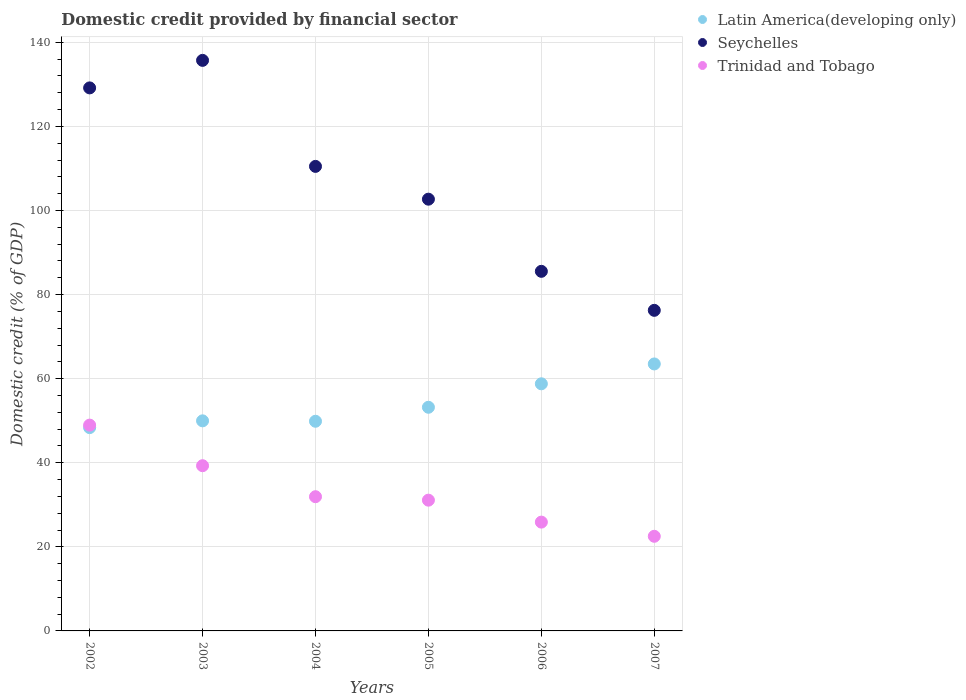How many different coloured dotlines are there?
Your answer should be very brief. 3. What is the domestic credit in Seychelles in 2006?
Keep it short and to the point. 85.53. Across all years, what is the maximum domestic credit in Latin America(developing only)?
Keep it short and to the point. 63.5. Across all years, what is the minimum domestic credit in Seychelles?
Provide a short and direct response. 76.25. What is the total domestic credit in Trinidad and Tobago in the graph?
Your answer should be very brief. 199.66. What is the difference between the domestic credit in Latin America(developing only) in 2004 and that in 2005?
Your answer should be very brief. -3.33. What is the difference between the domestic credit in Trinidad and Tobago in 2002 and the domestic credit in Latin America(developing only) in 2005?
Provide a short and direct response. -4.25. What is the average domestic credit in Latin America(developing only) per year?
Provide a short and direct response. 53.95. In the year 2007, what is the difference between the domestic credit in Latin America(developing only) and domestic credit in Trinidad and Tobago?
Offer a very short reply. 40.99. In how many years, is the domestic credit in Latin America(developing only) greater than 56 %?
Provide a short and direct response. 2. What is the ratio of the domestic credit in Latin America(developing only) in 2002 to that in 2005?
Your answer should be very brief. 0.91. Is the domestic credit in Trinidad and Tobago in 2003 less than that in 2005?
Provide a succinct answer. No. Is the difference between the domestic credit in Latin America(developing only) in 2002 and 2003 greater than the difference between the domestic credit in Trinidad and Tobago in 2002 and 2003?
Keep it short and to the point. No. What is the difference between the highest and the second highest domestic credit in Latin America(developing only)?
Your answer should be compact. 4.72. What is the difference between the highest and the lowest domestic credit in Latin America(developing only)?
Keep it short and to the point. 15.15. In how many years, is the domestic credit in Trinidad and Tobago greater than the average domestic credit in Trinidad and Tobago taken over all years?
Your answer should be compact. 2. Is the sum of the domestic credit in Seychelles in 2004 and 2006 greater than the maximum domestic credit in Trinidad and Tobago across all years?
Offer a very short reply. Yes. Is it the case that in every year, the sum of the domestic credit in Seychelles and domestic credit in Trinidad and Tobago  is greater than the domestic credit in Latin America(developing only)?
Ensure brevity in your answer.  Yes. Does the domestic credit in Latin America(developing only) monotonically increase over the years?
Your response must be concise. No. Is the domestic credit in Latin America(developing only) strictly less than the domestic credit in Trinidad and Tobago over the years?
Provide a succinct answer. No. Does the graph contain any zero values?
Give a very brief answer. No. Does the graph contain grids?
Offer a terse response. Yes. How many legend labels are there?
Offer a terse response. 3. How are the legend labels stacked?
Offer a very short reply. Vertical. What is the title of the graph?
Give a very brief answer. Domestic credit provided by financial sector. What is the label or title of the X-axis?
Make the answer very short. Years. What is the label or title of the Y-axis?
Provide a succinct answer. Domestic credit (% of GDP). What is the Domestic credit (% of GDP) of Latin America(developing only) in 2002?
Keep it short and to the point. 48.36. What is the Domestic credit (% of GDP) in Seychelles in 2002?
Offer a very short reply. 129.16. What is the Domestic credit (% of GDP) of Trinidad and Tobago in 2002?
Give a very brief answer. 48.95. What is the Domestic credit (% of GDP) of Latin America(developing only) in 2003?
Make the answer very short. 49.97. What is the Domestic credit (% of GDP) of Seychelles in 2003?
Ensure brevity in your answer.  135.71. What is the Domestic credit (% of GDP) of Trinidad and Tobago in 2003?
Your response must be concise. 39.3. What is the Domestic credit (% of GDP) in Latin America(developing only) in 2004?
Give a very brief answer. 49.87. What is the Domestic credit (% of GDP) in Seychelles in 2004?
Your answer should be very brief. 110.49. What is the Domestic credit (% of GDP) of Trinidad and Tobago in 2004?
Make the answer very short. 31.92. What is the Domestic credit (% of GDP) of Latin America(developing only) in 2005?
Your answer should be very brief. 53.2. What is the Domestic credit (% of GDP) in Seychelles in 2005?
Your response must be concise. 102.69. What is the Domestic credit (% of GDP) of Trinidad and Tobago in 2005?
Your answer should be compact. 31.1. What is the Domestic credit (% of GDP) of Latin America(developing only) in 2006?
Your answer should be very brief. 58.78. What is the Domestic credit (% of GDP) of Seychelles in 2006?
Your answer should be compact. 85.53. What is the Domestic credit (% of GDP) in Trinidad and Tobago in 2006?
Provide a short and direct response. 25.88. What is the Domestic credit (% of GDP) of Latin America(developing only) in 2007?
Your answer should be very brief. 63.5. What is the Domestic credit (% of GDP) in Seychelles in 2007?
Provide a short and direct response. 76.25. What is the Domestic credit (% of GDP) of Trinidad and Tobago in 2007?
Offer a terse response. 22.51. Across all years, what is the maximum Domestic credit (% of GDP) of Latin America(developing only)?
Provide a succinct answer. 63.5. Across all years, what is the maximum Domestic credit (% of GDP) in Seychelles?
Give a very brief answer. 135.71. Across all years, what is the maximum Domestic credit (% of GDP) in Trinidad and Tobago?
Provide a short and direct response. 48.95. Across all years, what is the minimum Domestic credit (% of GDP) in Latin America(developing only)?
Keep it short and to the point. 48.36. Across all years, what is the minimum Domestic credit (% of GDP) in Seychelles?
Give a very brief answer. 76.25. Across all years, what is the minimum Domestic credit (% of GDP) in Trinidad and Tobago?
Offer a very short reply. 22.51. What is the total Domestic credit (% of GDP) of Latin America(developing only) in the graph?
Make the answer very short. 323.67. What is the total Domestic credit (% of GDP) in Seychelles in the graph?
Offer a terse response. 639.84. What is the total Domestic credit (% of GDP) of Trinidad and Tobago in the graph?
Keep it short and to the point. 199.66. What is the difference between the Domestic credit (% of GDP) in Latin America(developing only) in 2002 and that in 2003?
Offer a terse response. -1.61. What is the difference between the Domestic credit (% of GDP) in Seychelles in 2002 and that in 2003?
Provide a short and direct response. -6.55. What is the difference between the Domestic credit (% of GDP) of Trinidad and Tobago in 2002 and that in 2003?
Provide a short and direct response. 9.65. What is the difference between the Domestic credit (% of GDP) in Latin America(developing only) in 2002 and that in 2004?
Offer a terse response. -1.51. What is the difference between the Domestic credit (% of GDP) of Seychelles in 2002 and that in 2004?
Keep it short and to the point. 18.67. What is the difference between the Domestic credit (% of GDP) in Trinidad and Tobago in 2002 and that in 2004?
Your answer should be compact. 17.03. What is the difference between the Domestic credit (% of GDP) of Latin America(developing only) in 2002 and that in 2005?
Provide a succinct answer. -4.84. What is the difference between the Domestic credit (% of GDP) of Seychelles in 2002 and that in 2005?
Keep it short and to the point. 26.47. What is the difference between the Domestic credit (% of GDP) in Trinidad and Tobago in 2002 and that in 2005?
Provide a succinct answer. 17.85. What is the difference between the Domestic credit (% of GDP) of Latin America(developing only) in 2002 and that in 2006?
Keep it short and to the point. -10.42. What is the difference between the Domestic credit (% of GDP) of Seychelles in 2002 and that in 2006?
Your answer should be compact. 43.63. What is the difference between the Domestic credit (% of GDP) in Trinidad and Tobago in 2002 and that in 2006?
Give a very brief answer. 23.07. What is the difference between the Domestic credit (% of GDP) of Latin America(developing only) in 2002 and that in 2007?
Provide a short and direct response. -15.15. What is the difference between the Domestic credit (% of GDP) of Seychelles in 2002 and that in 2007?
Give a very brief answer. 52.91. What is the difference between the Domestic credit (% of GDP) of Trinidad and Tobago in 2002 and that in 2007?
Give a very brief answer. 26.44. What is the difference between the Domestic credit (% of GDP) in Latin America(developing only) in 2003 and that in 2004?
Provide a succinct answer. 0.1. What is the difference between the Domestic credit (% of GDP) of Seychelles in 2003 and that in 2004?
Your answer should be compact. 25.22. What is the difference between the Domestic credit (% of GDP) of Trinidad and Tobago in 2003 and that in 2004?
Keep it short and to the point. 7.37. What is the difference between the Domestic credit (% of GDP) in Latin America(developing only) in 2003 and that in 2005?
Provide a short and direct response. -3.23. What is the difference between the Domestic credit (% of GDP) in Seychelles in 2003 and that in 2005?
Keep it short and to the point. 33.02. What is the difference between the Domestic credit (% of GDP) in Trinidad and Tobago in 2003 and that in 2005?
Your response must be concise. 8.2. What is the difference between the Domestic credit (% of GDP) of Latin America(developing only) in 2003 and that in 2006?
Your answer should be very brief. -8.81. What is the difference between the Domestic credit (% of GDP) of Seychelles in 2003 and that in 2006?
Your response must be concise. 50.18. What is the difference between the Domestic credit (% of GDP) in Trinidad and Tobago in 2003 and that in 2006?
Your answer should be very brief. 13.42. What is the difference between the Domestic credit (% of GDP) in Latin America(developing only) in 2003 and that in 2007?
Offer a very short reply. -13.53. What is the difference between the Domestic credit (% of GDP) of Seychelles in 2003 and that in 2007?
Make the answer very short. 59.46. What is the difference between the Domestic credit (% of GDP) in Trinidad and Tobago in 2003 and that in 2007?
Make the answer very short. 16.79. What is the difference between the Domestic credit (% of GDP) of Latin America(developing only) in 2004 and that in 2005?
Ensure brevity in your answer.  -3.33. What is the difference between the Domestic credit (% of GDP) in Seychelles in 2004 and that in 2005?
Ensure brevity in your answer.  7.8. What is the difference between the Domestic credit (% of GDP) of Trinidad and Tobago in 2004 and that in 2005?
Keep it short and to the point. 0.82. What is the difference between the Domestic credit (% of GDP) in Latin America(developing only) in 2004 and that in 2006?
Offer a very short reply. -8.91. What is the difference between the Domestic credit (% of GDP) in Seychelles in 2004 and that in 2006?
Provide a short and direct response. 24.96. What is the difference between the Domestic credit (% of GDP) in Trinidad and Tobago in 2004 and that in 2006?
Make the answer very short. 6.04. What is the difference between the Domestic credit (% of GDP) in Latin America(developing only) in 2004 and that in 2007?
Keep it short and to the point. -13.63. What is the difference between the Domestic credit (% of GDP) of Seychelles in 2004 and that in 2007?
Ensure brevity in your answer.  34.24. What is the difference between the Domestic credit (% of GDP) of Trinidad and Tobago in 2004 and that in 2007?
Ensure brevity in your answer.  9.42. What is the difference between the Domestic credit (% of GDP) in Latin America(developing only) in 2005 and that in 2006?
Give a very brief answer. -5.58. What is the difference between the Domestic credit (% of GDP) in Seychelles in 2005 and that in 2006?
Ensure brevity in your answer.  17.16. What is the difference between the Domestic credit (% of GDP) of Trinidad and Tobago in 2005 and that in 2006?
Give a very brief answer. 5.22. What is the difference between the Domestic credit (% of GDP) in Latin America(developing only) in 2005 and that in 2007?
Your response must be concise. -10.3. What is the difference between the Domestic credit (% of GDP) of Seychelles in 2005 and that in 2007?
Offer a terse response. 26.44. What is the difference between the Domestic credit (% of GDP) of Trinidad and Tobago in 2005 and that in 2007?
Ensure brevity in your answer.  8.59. What is the difference between the Domestic credit (% of GDP) in Latin America(developing only) in 2006 and that in 2007?
Your response must be concise. -4.72. What is the difference between the Domestic credit (% of GDP) in Seychelles in 2006 and that in 2007?
Your answer should be very brief. 9.28. What is the difference between the Domestic credit (% of GDP) of Trinidad and Tobago in 2006 and that in 2007?
Provide a short and direct response. 3.37. What is the difference between the Domestic credit (% of GDP) in Latin America(developing only) in 2002 and the Domestic credit (% of GDP) in Seychelles in 2003?
Ensure brevity in your answer.  -87.35. What is the difference between the Domestic credit (% of GDP) of Latin America(developing only) in 2002 and the Domestic credit (% of GDP) of Trinidad and Tobago in 2003?
Your response must be concise. 9.06. What is the difference between the Domestic credit (% of GDP) of Seychelles in 2002 and the Domestic credit (% of GDP) of Trinidad and Tobago in 2003?
Your answer should be very brief. 89.87. What is the difference between the Domestic credit (% of GDP) in Latin America(developing only) in 2002 and the Domestic credit (% of GDP) in Seychelles in 2004?
Your answer should be compact. -62.14. What is the difference between the Domestic credit (% of GDP) in Latin America(developing only) in 2002 and the Domestic credit (% of GDP) in Trinidad and Tobago in 2004?
Offer a very short reply. 16.43. What is the difference between the Domestic credit (% of GDP) of Seychelles in 2002 and the Domestic credit (% of GDP) of Trinidad and Tobago in 2004?
Keep it short and to the point. 97.24. What is the difference between the Domestic credit (% of GDP) in Latin America(developing only) in 2002 and the Domestic credit (% of GDP) in Seychelles in 2005?
Keep it short and to the point. -54.34. What is the difference between the Domestic credit (% of GDP) in Latin America(developing only) in 2002 and the Domestic credit (% of GDP) in Trinidad and Tobago in 2005?
Ensure brevity in your answer.  17.26. What is the difference between the Domestic credit (% of GDP) in Seychelles in 2002 and the Domestic credit (% of GDP) in Trinidad and Tobago in 2005?
Offer a very short reply. 98.06. What is the difference between the Domestic credit (% of GDP) in Latin America(developing only) in 2002 and the Domestic credit (% of GDP) in Seychelles in 2006?
Keep it short and to the point. -37.18. What is the difference between the Domestic credit (% of GDP) in Latin America(developing only) in 2002 and the Domestic credit (% of GDP) in Trinidad and Tobago in 2006?
Make the answer very short. 22.48. What is the difference between the Domestic credit (% of GDP) in Seychelles in 2002 and the Domestic credit (% of GDP) in Trinidad and Tobago in 2006?
Ensure brevity in your answer.  103.28. What is the difference between the Domestic credit (% of GDP) of Latin America(developing only) in 2002 and the Domestic credit (% of GDP) of Seychelles in 2007?
Offer a terse response. -27.9. What is the difference between the Domestic credit (% of GDP) of Latin America(developing only) in 2002 and the Domestic credit (% of GDP) of Trinidad and Tobago in 2007?
Offer a terse response. 25.85. What is the difference between the Domestic credit (% of GDP) of Seychelles in 2002 and the Domestic credit (% of GDP) of Trinidad and Tobago in 2007?
Offer a terse response. 106.66. What is the difference between the Domestic credit (% of GDP) in Latin America(developing only) in 2003 and the Domestic credit (% of GDP) in Seychelles in 2004?
Offer a terse response. -60.52. What is the difference between the Domestic credit (% of GDP) in Latin America(developing only) in 2003 and the Domestic credit (% of GDP) in Trinidad and Tobago in 2004?
Give a very brief answer. 18.04. What is the difference between the Domestic credit (% of GDP) in Seychelles in 2003 and the Domestic credit (% of GDP) in Trinidad and Tobago in 2004?
Your answer should be compact. 103.79. What is the difference between the Domestic credit (% of GDP) in Latin America(developing only) in 2003 and the Domestic credit (% of GDP) in Seychelles in 2005?
Make the answer very short. -52.72. What is the difference between the Domestic credit (% of GDP) of Latin America(developing only) in 2003 and the Domestic credit (% of GDP) of Trinidad and Tobago in 2005?
Provide a succinct answer. 18.87. What is the difference between the Domestic credit (% of GDP) of Seychelles in 2003 and the Domestic credit (% of GDP) of Trinidad and Tobago in 2005?
Your response must be concise. 104.61. What is the difference between the Domestic credit (% of GDP) of Latin America(developing only) in 2003 and the Domestic credit (% of GDP) of Seychelles in 2006?
Provide a short and direct response. -35.56. What is the difference between the Domestic credit (% of GDP) of Latin America(developing only) in 2003 and the Domestic credit (% of GDP) of Trinidad and Tobago in 2006?
Offer a very short reply. 24.09. What is the difference between the Domestic credit (% of GDP) in Seychelles in 2003 and the Domestic credit (% of GDP) in Trinidad and Tobago in 2006?
Make the answer very short. 109.83. What is the difference between the Domestic credit (% of GDP) in Latin America(developing only) in 2003 and the Domestic credit (% of GDP) in Seychelles in 2007?
Provide a short and direct response. -26.28. What is the difference between the Domestic credit (% of GDP) in Latin America(developing only) in 2003 and the Domestic credit (% of GDP) in Trinidad and Tobago in 2007?
Offer a terse response. 27.46. What is the difference between the Domestic credit (% of GDP) in Seychelles in 2003 and the Domestic credit (% of GDP) in Trinidad and Tobago in 2007?
Offer a terse response. 113.2. What is the difference between the Domestic credit (% of GDP) of Latin America(developing only) in 2004 and the Domestic credit (% of GDP) of Seychelles in 2005?
Your answer should be very brief. -52.82. What is the difference between the Domestic credit (% of GDP) of Latin America(developing only) in 2004 and the Domestic credit (% of GDP) of Trinidad and Tobago in 2005?
Your answer should be very brief. 18.77. What is the difference between the Domestic credit (% of GDP) in Seychelles in 2004 and the Domestic credit (% of GDP) in Trinidad and Tobago in 2005?
Your response must be concise. 79.39. What is the difference between the Domestic credit (% of GDP) of Latin America(developing only) in 2004 and the Domestic credit (% of GDP) of Seychelles in 2006?
Ensure brevity in your answer.  -35.66. What is the difference between the Domestic credit (% of GDP) of Latin America(developing only) in 2004 and the Domestic credit (% of GDP) of Trinidad and Tobago in 2006?
Your answer should be very brief. 23.99. What is the difference between the Domestic credit (% of GDP) in Seychelles in 2004 and the Domestic credit (% of GDP) in Trinidad and Tobago in 2006?
Keep it short and to the point. 84.61. What is the difference between the Domestic credit (% of GDP) in Latin America(developing only) in 2004 and the Domestic credit (% of GDP) in Seychelles in 2007?
Offer a terse response. -26.38. What is the difference between the Domestic credit (% of GDP) of Latin America(developing only) in 2004 and the Domestic credit (% of GDP) of Trinidad and Tobago in 2007?
Offer a terse response. 27.36. What is the difference between the Domestic credit (% of GDP) of Seychelles in 2004 and the Domestic credit (% of GDP) of Trinidad and Tobago in 2007?
Offer a very short reply. 87.98. What is the difference between the Domestic credit (% of GDP) of Latin America(developing only) in 2005 and the Domestic credit (% of GDP) of Seychelles in 2006?
Offer a very short reply. -32.33. What is the difference between the Domestic credit (% of GDP) of Latin America(developing only) in 2005 and the Domestic credit (% of GDP) of Trinidad and Tobago in 2006?
Provide a short and direct response. 27.32. What is the difference between the Domestic credit (% of GDP) in Seychelles in 2005 and the Domestic credit (% of GDP) in Trinidad and Tobago in 2006?
Make the answer very short. 76.81. What is the difference between the Domestic credit (% of GDP) of Latin America(developing only) in 2005 and the Domestic credit (% of GDP) of Seychelles in 2007?
Give a very brief answer. -23.05. What is the difference between the Domestic credit (% of GDP) in Latin America(developing only) in 2005 and the Domestic credit (% of GDP) in Trinidad and Tobago in 2007?
Ensure brevity in your answer.  30.69. What is the difference between the Domestic credit (% of GDP) in Seychelles in 2005 and the Domestic credit (% of GDP) in Trinidad and Tobago in 2007?
Your response must be concise. 80.19. What is the difference between the Domestic credit (% of GDP) of Latin America(developing only) in 2006 and the Domestic credit (% of GDP) of Seychelles in 2007?
Your answer should be compact. -17.47. What is the difference between the Domestic credit (% of GDP) of Latin America(developing only) in 2006 and the Domestic credit (% of GDP) of Trinidad and Tobago in 2007?
Provide a short and direct response. 36.27. What is the difference between the Domestic credit (% of GDP) in Seychelles in 2006 and the Domestic credit (% of GDP) in Trinidad and Tobago in 2007?
Keep it short and to the point. 63.02. What is the average Domestic credit (% of GDP) of Latin America(developing only) per year?
Your answer should be very brief. 53.95. What is the average Domestic credit (% of GDP) in Seychelles per year?
Provide a succinct answer. 106.64. What is the average Domestic credit (% of GDP) in Trinidad and Tobago per year?
Offer a terse response. 33.28. In the year 2002, what is the difference between the Domestic credit (% of GDP) of Latin America(developing only) and Domestic credit (% of GDP) of Seychelles?
Provide a short and direct response. -80.81. In the year 2002, what is the difference between the Domestic credit (% of GDP) in Latin America(developing only) and Domestic credit (% of GDP) in Trinidad and Tobago?
Provide a succinct answer. -0.6. In the year 2002, what is the difference between the Domestic credit (% of GDP) of Seychelles and Domestic credit (% of GDP) of Trinidad and Tobago?
Provide a short and direct response. 80.21. In the year 2003, what is the difference between the Domestic credit (% of GDP) in Latin America(developing only) and Domestic credit (% of GDP) in Seychelles?
Give a very brief answer. -85.74. In the year 2003, what is the difference between the Domestic credit (% of GDP) in Latin America(developing only) and Domestic credit (% of GDP) in Trinidad and Tobago?
Your answer should be very brief. 10.67. In the year 2003, what is the difference between the Domestic credit (% of GDP) in Seychelles and Domestic credit (% of GDP) in Trinidad and Tobago?
Offer a terse response. 96.41. In the year 2004, what is the difference between the Domestic credit (% of GDP) in Latin America(developing only) and Domestic credit (% of GDP) in Seychelles?
Your answer should be compact. -60.62. In the year 2004, what is the difference between the Domestic credit (% of GDP) in Latin America(developing only) and Domestic credit (% of GDP) in Trinidad and Tobago?
Offer a very short reply. 17.95. In the year 2004, what is the difference between the Domestic credit (% of GDP) of Seychelles and Domestic credit (% of GDP) of Trinidad and Tobago?
Your answer should be very brief. 78.57. In the year 2005, what is the difference between the Domestic credit (% of GDP) of Latin America(developing only) and Domestic credit (% of GDP) of Seychelles?
Keep it short and to the point. -49.49. In the year 2005, what is the difference between the Domestic credit (% of GDP) in Latin America(developing only) and Domestic credit (% of GDP) in Trinidad and Tobago?
Your answer should be compact. 22.1. In the year 2005, what is the difference between the Domestic credit (% of GDP) in Seychelles and Domestic credit (% of GDP) in Trinidad and Tobago?
Offer a terse response. 71.59. In the year 2006, what is the difference between the Domestic credit (% of GDP) in Latin America(developing only) and Domestic credit (% of GDP) in Seychelles?
Provide a short and direct response. -26.75. In the year 2006, what is the difference between the Domestic credit (% of GDP) in Latin America(developing only) and Domestic credit (% of GDP) in Trinidad and Tobago?
Offer a very short reply. 32.9. In the year 2006, what is the difference between the Domestic credit (% of GDP) of Seychelles and Domestic credit (% of GDP) of Trinidad and Tobago?
Make the answer very short. 59.65. In the year 2007, what is the difference between the Domestic credit (% of GDP) in Latin America(developing only) and Domestic credit (% of GDP) in Seychelles?
Keep it short and to the point. -12.75. In the year 2007, what is the difference between the Domestic credit (% of GDP) in Latin America(developing only) and Domestic credit (% of GDP) in Trinidad and Tobago?
Your answer should be compact. 40.99. In the year 2007, what is the difference between the Domestic credit (% of GDP) of Seychelles and Domestic credit (% of GDP) of Trinidad and Tobago?
Make the answer very short. 53.74. What is the ratio of the Domestic credit (% of GDP) in Latin America(developing only) in 2002 to that in 2003?
Make the answer very short. 0.97. What is the ratio of the Domestic credit (% of GDP) of Seychelles in 2002 to that in 2003?
Provide a succinct answer. 0.95. What is the ratio of the Domestic credit (% of GDP) of Trinidad and Tobago in 2002 to that in 2003?
Make the answer very short. 1.25. What is the ratio of the Domestic credit (% of GDP) of Latin America(developing only) in 2002 to that in 2004?
Provide a succinct answer. 0.97. What is the ratio of the Domestic credit (% of GDP) of Seychelles in 2002 to that in 2004?
Provide a succinct answer. 1.17. What is the ratio of the Domestic credit (% of GDP) in Trinidad and Tobago in 2002 to that in 2004?
Provide a succinct answer. 1.53. What is the ratio of the Domestic credit (% of GDP) of Latin America(developing only) in 2002 to that in 2005?
Provide a short and direct response. 0.91. What is the ratio of the Domestic credit (% of GDP) in Seychelles in 2002 to that in 2005?
Offer a terse response. 1.26. What is the ratio of the Domestic credit (% of GDP) in Trinidad and Tobago in 2002 to that in 2005?
Make the answer very short. 1.57. What is the ratio of the Domestic credit (% of GDP) of Latin America(developing only) in 2002 to that in 2006?
Give a very brief answer. 0.82. What is the ratio of the Domestic credit (% of GDP) of Seychelles in 2002 to that in 2006?
Provide a short and direct response. 1.51. What is the ratio of the Domestic credit (% of GDP) of Trinidad and Tobago in 2002 to that in 2006?
Your answer should be very brief. 1.89. What is the ratio of the Domestic credit (% of GDP) of Latin America(developing only) in 2002 to that in 2007?
Provide a succinct answer. 0.76. What is the ratio of the Domestic credit (% of GDP) in Seychelles in 2002 to that in 2007?
Your answer should be compact. 1.69. What is the ratio of the Domestic credit (% of GDP) in Trinidad and Tobago in 2002 to that in 2007?
Give a very brief answer. 2.17. What is the ratio of the Domestic credit (% of GDP) of Latin America(developing only) in 2003 to that in 2004?
Make the answer very short. 1. What is the ratio of the Domestic credit (% of GDP) in Seychelles in 2003 to that in 2004?
Keep it short and to the point. 1.23. What is the ratio of the Domestic credit (% of GDP) of Trinidad and Tobago in 2003 to that in 2004?
Keep it short and to the point. 1.23. What is the ratio of the Domestic credit (% of GDP) in Latin America(developing only) in 2003 to that in 2005?
Give a very brief answer. 0.94. What is the ratio of the Domestic credit (% of GDP) in Seychelles in 2003 to that in 2005?
Offer a very short reply. 1.32. What is the ratio of the Domestic credit (% of GDP) in Trinidad and Tobago in 2003 to that in 2005?
Ensure brevity in your answer.  1.26. What is the ratio of the Domestic credit (% of GDP) in Latin America(developing only) in 2003 to that in 2006?
Your answer should be very brief. 0.85. What is the ratio of the Domestic credit (% of GDP) of Seychelles in 2003 to that in 2006?
Make the answer very short. 1.59. What is the ratio of the Domestic credit (% of GDP) of Trinidad and Tobago in 2003 to that in 2006?
Your answer should be compact. 1.52. What is the ratio of the Domestic credit (% of GDP) in Latin America(developing only) in 2003 to that in 2007?
Offer a terse response. 0.79. What is the ratio of the Domestic credit (% of GDP) in Seychelles in 2003 to that in 2007?
Make the answer very short. 1.78. What is the ratio of the Domestic credit (% of GDP) of Trinidad and Tobago in 2003 to that in 2007?
Provide a succinct answer. 1.75. What is the ratio of the Domestic credit (% of GDP) of Latin America(developing only) in 2004 to that in 2005?
Offer a very short reply. 0.94. What is the ratio of the Domestic credit (% of GDP) in Seychelles in 2004 to that in 2005?
Make the answer very short. 1.08. What is the ratio of the Domestic credit (% of GDP) of Trinidad and Tobago in 2004 to that in 2005?
Provide a succinct answer. 1.03. What is the ratio of the Domestic credit (% of GDP) of Latin America(developing only) in 2004 to that in 2006?
Your response must be concise. 0.85. What is the ratio of the Domestic credit (% of GDP) of Seychelles in 2004 to that in 2006?
Your answer should be very brief. 1.29. What is the ratio of the Domestic credit (% of GDP) of Trinidad and Tobago in 2004 to that in 2006?
Your answer should be compact. 1.23. What is the ratio of the Domestic credit (% of GDP) of Latin America(developing only) in 2004 to that in 2007?
Your response must be concise. 0.79. What is the ratio of the Domestic credit (% of GDP) in Seychelles in 2004 to that in 2007?
Make the answer very short. 1.45. What is the ratio of the Domestic credit (% of GDP) in Trinidad and Tobago in 2004 to that in 2007?
Provide a short and direct response. 1.42. What is the ratio of the Domestic credit (% of GDP) in Latin America(developing only) in 2005 to that in 2006?
Ensure brevity in your answer.  0.91. What is the ratio of the Domestic credit (% of GDP) in Seychelles in 2005 to that in 2006?
Ensure brevity in your answer.  1.2. What is the ratio of the Domestic credit (% of GDP) in Trinidad and Tobago in 2005 to that in 2006?
Ensure brevity in your answer.  1.2. What is the ratio of the Domestic credit (% of GDP) of Latin America(developing only) in 2005 to that in 2007?
Your response must be concise. 0.84. What is the ratio of the Domestic credit (% of GDP) of Seychelles in 2005 to that in 2007?
Your answer should be compact. 1.35. What is the ratio of the Domestic credit (% of GDP) of Trinidad and Tobago in 2005 to that in 2007?
Your answer should be compact. 1.38. What is the ratio of the Domestic credit (% of GDP) in Latin America(developing only) in 2006 to that in 2007?
Ensure brevity in your answer.  0.93. What is the ratio of the Domestic credit (% of GDP) in Seychelles in 2006 to that in 2007?
Ensure brevity in your answer.  1.12. What is the ratio of the Domestic credit (% of GDP) in Trinidad and Tobago in 2006 to that in 2007?
Offer a terse response. 1.15. What is the difference between the highest and the second highest Domestic credit (% of GDP) of Latin America(developing only)?
Ensure brevity in your answer.  4.72. What is the difference between the highest and the second highest Domestic credit (% of GDP) of Seychelles?
Your answer should be very brief. 6.55. What is the difference between the highest and the second highest Domestic credit (% of GDP) of Trinidad and Tobago?
Your response must be concise. 9.65. What is the difference between the highest and the lowest Domestic credit (% of GDP) in Latin America(developing only)?
Your answer should be compact. 15.15. What is the difference between the highest and the lowest Domestic credit (% of GDP) in Seychelles?
Your answer should be very brief. 59.46. What is the difference between the highest and the lowest Domestic credit (% of GDP) of Trinidad and Tobago?
Keep it short and to the point. 26.44. 